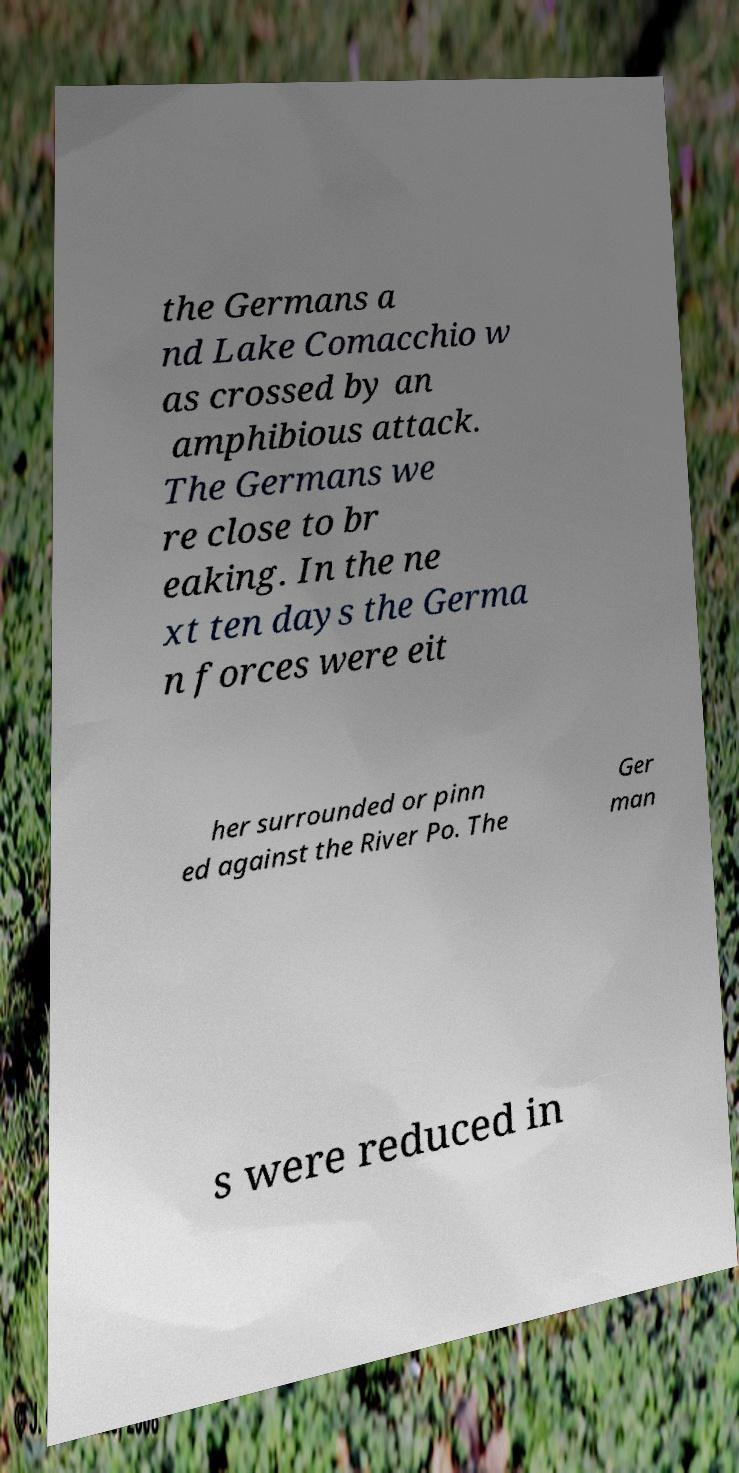What messages or text are displayed in this image? I need them in a readable, typed format. the Germans a nd Lake Comacchio w as crossed by an amphibious attack. The Germans we re close to br eaking. In the ne xt ten days the Germa n forces were eit her surrounded or pinn ed against the River Po. The Ger man s were reduced in 